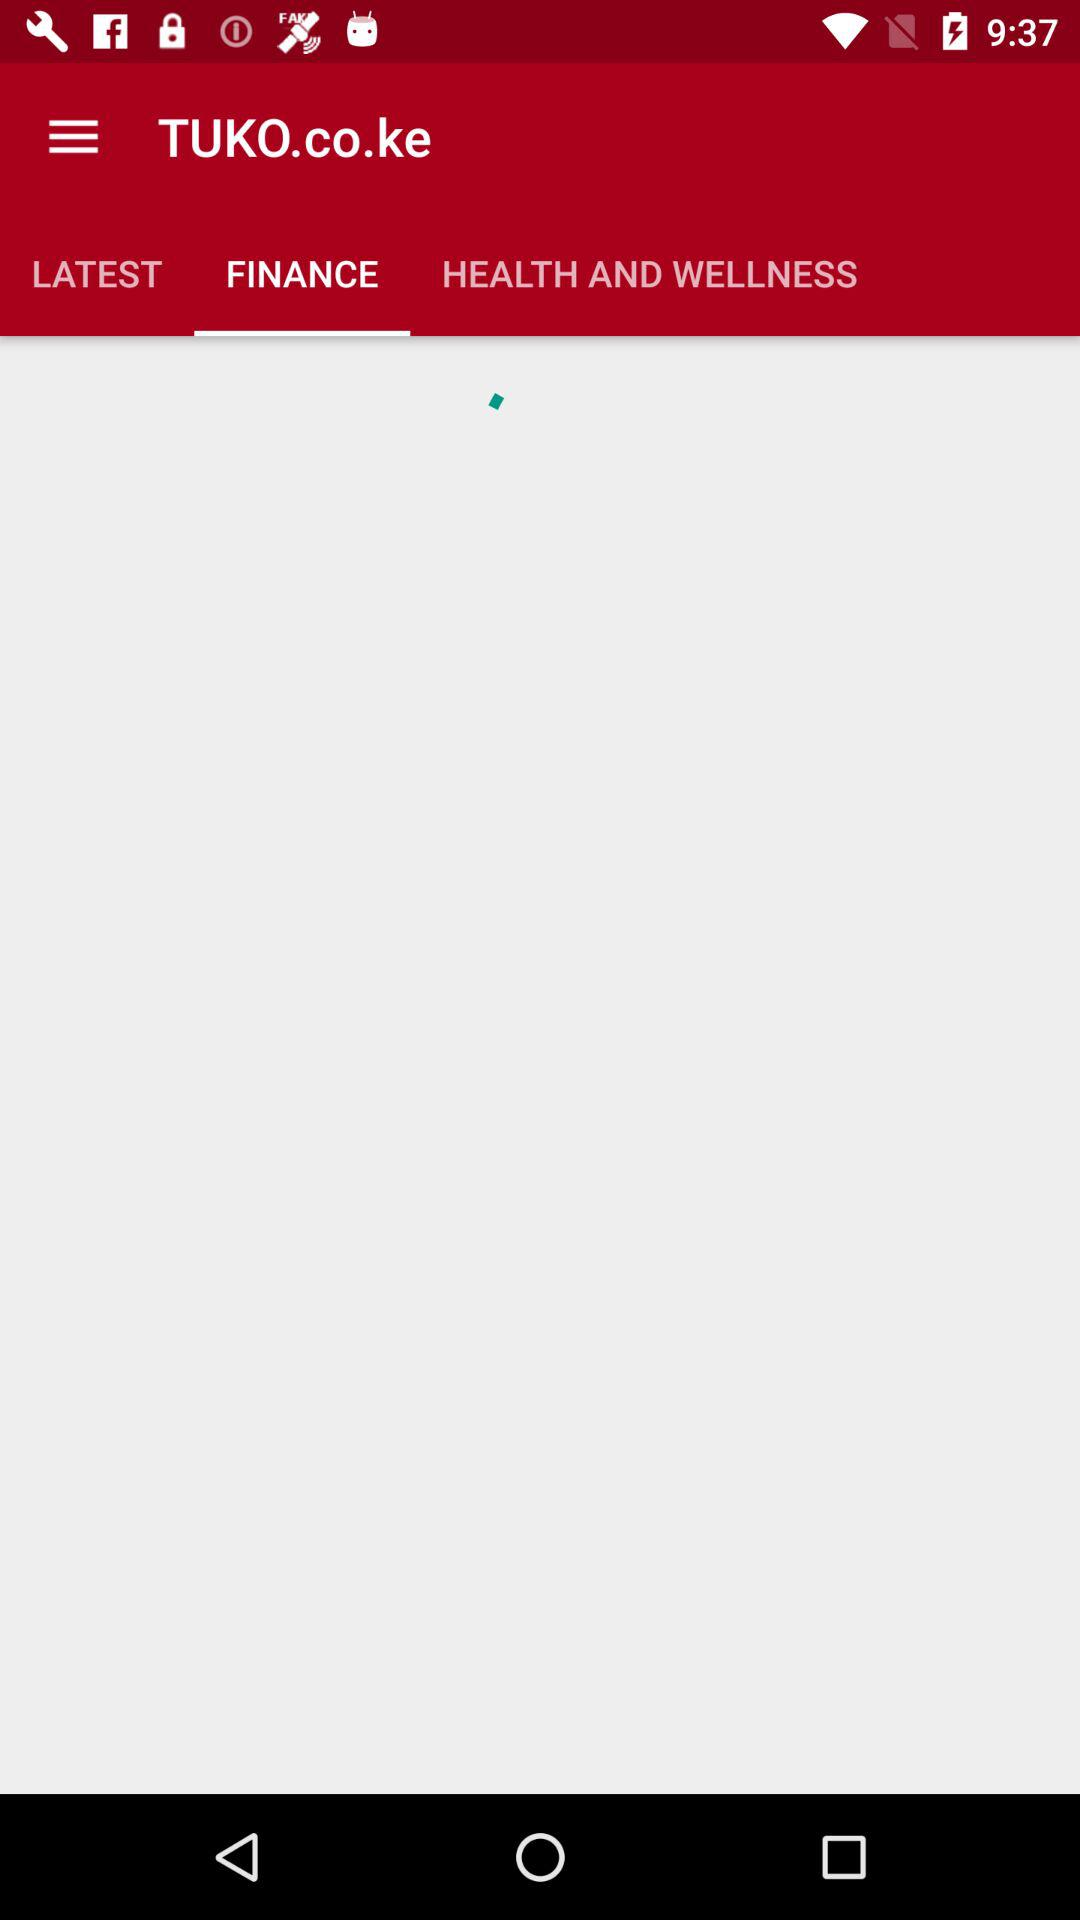Which option is selected for "TUKO.co.ke"? The selected option is "FINANCE". 